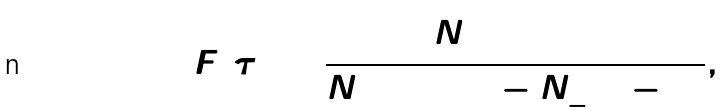Convert formula to latex. <formula><loc_0><loc_0><loc_500><loc_500>F ( \tau ) = \frac { N _ { + } ^ { 2 } ( 1 + \Gamma ) } { N _ { + } ^ { 2 } ( 1 + \Gamma ) - N _ { - } ^ { 2 } ( 1 - \Gamma ) } ,</formula> 